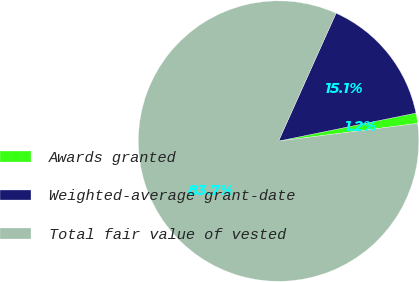<chart> <loc_0><loc_0><loc_500><loc_500><pie_chart><fcel>Awards granted<fcel>Weighted-average grant-date<fcel>Total fair value of vested<nl><fcel>1.19%<fcel>15.07%<fcel>83.74%<nl></chart> 